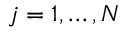<formula> <loc_0><loc_0><loc_500><loc_500>j = 1 , \dots , N</formula> 